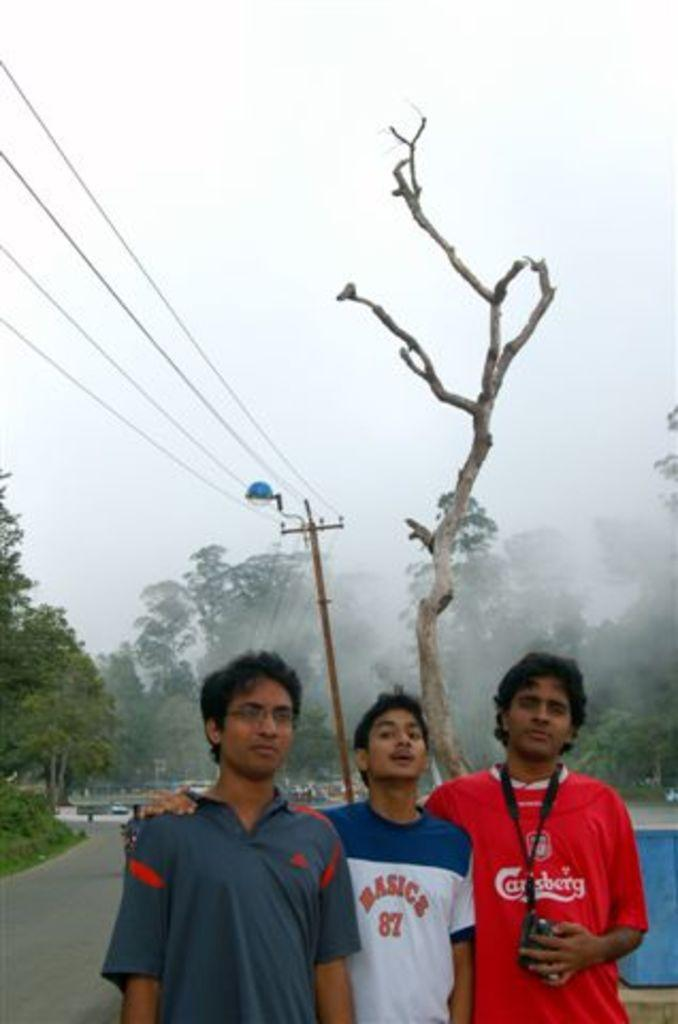<image>
Write a terse but informative summary of the picture. three boys and one with a basics shirt on 